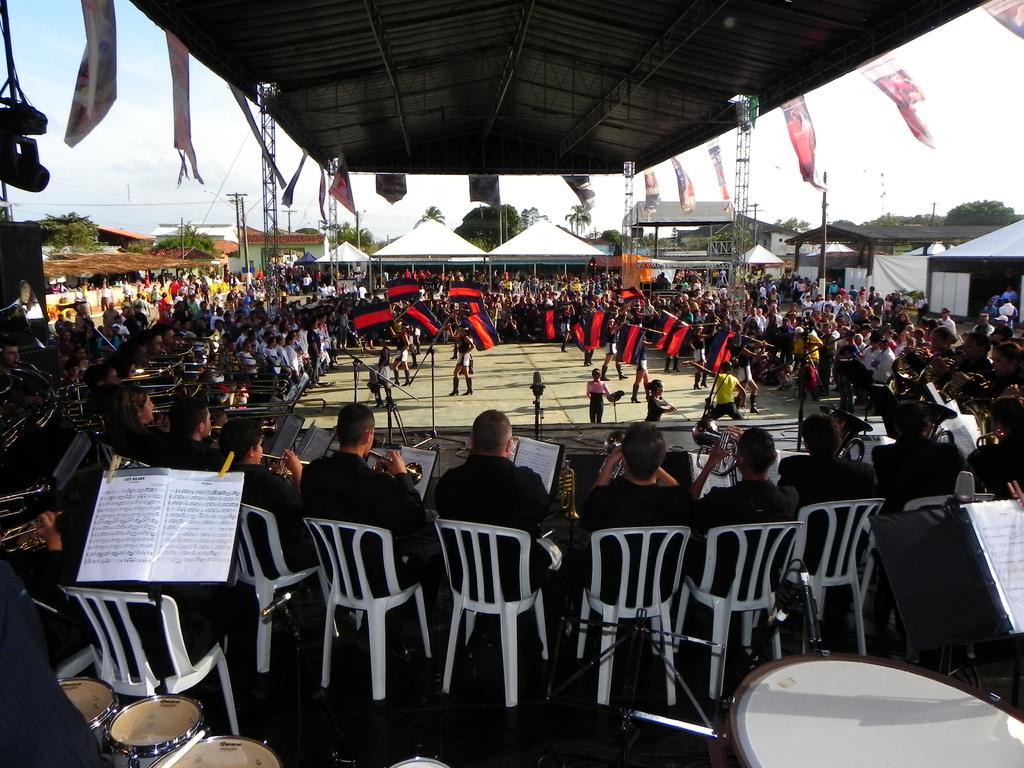How would you summarize this image in a sentence or two? This is the picture of a place where we have a lot of people sitting on the chairs and there are some postures to the roof and some bands and other tents around. 